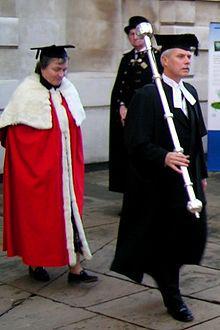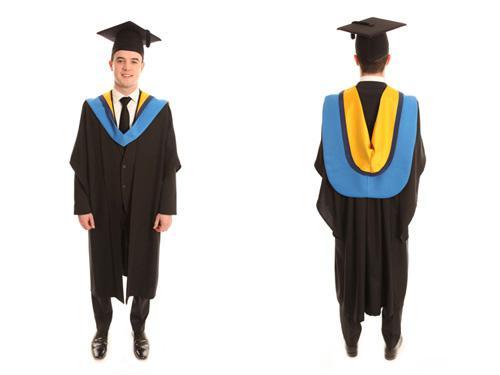The first image is the image on the left, the second image is the image on the right. For the images shown, is this caption "One person is wearing red." true? Answer yes or no. Yes. 